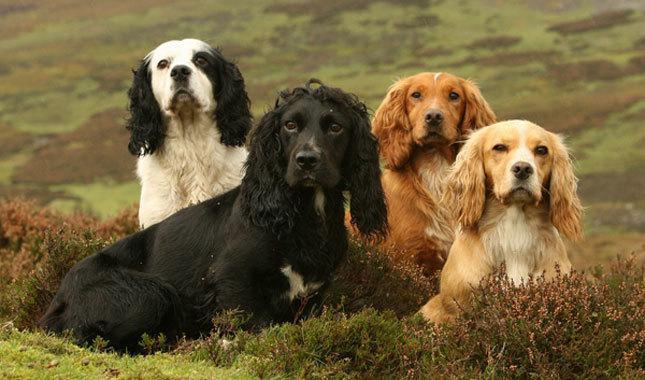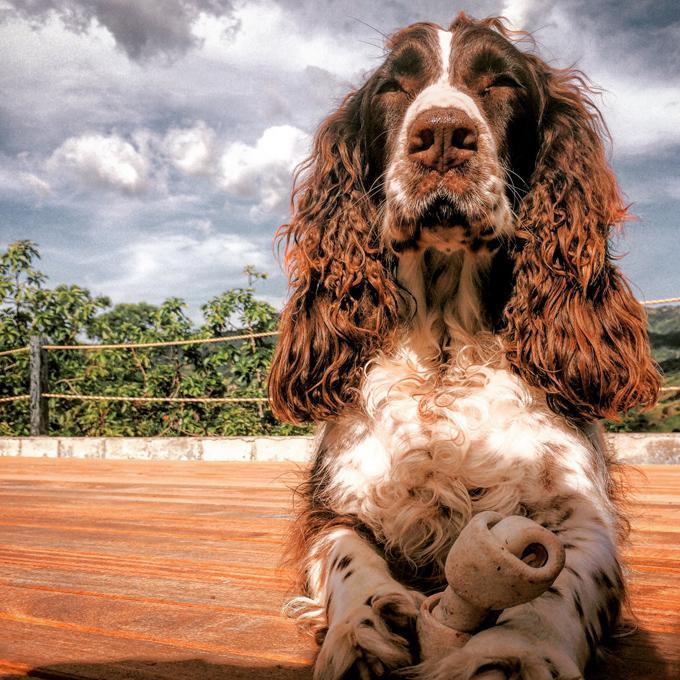The first image is the image on the left, the second image is the image on the right. Assess this claim about the two images: "There are three dogs". Correct or not? Answer yes or no. No. 